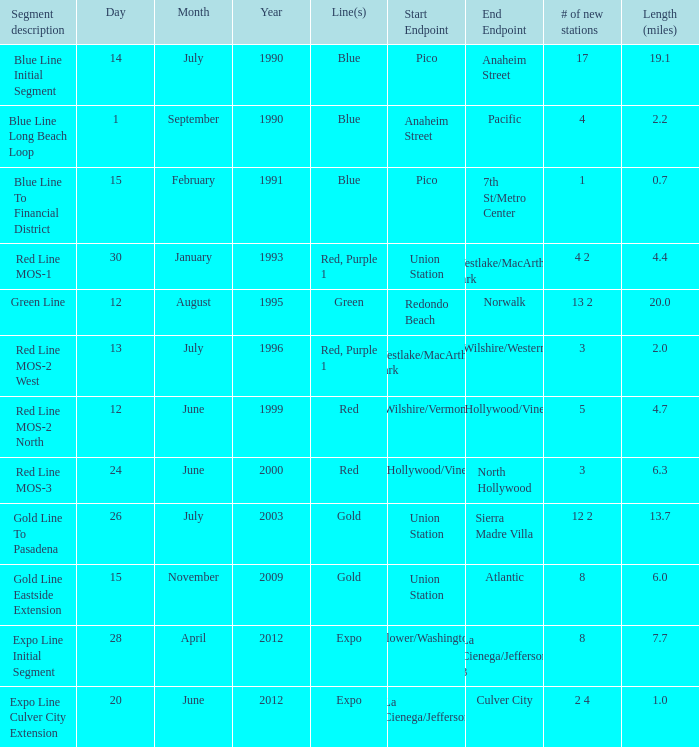0? 1.0. 